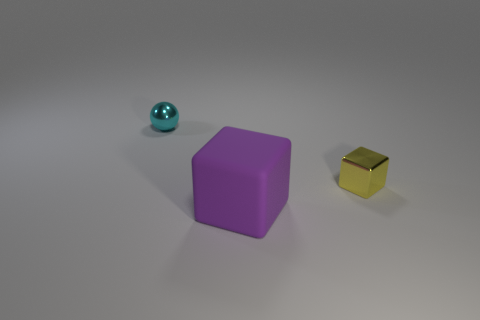Add 2 cyan spheres. How many objects exist? 5 Subtract all blue spheres. Subtract all red cubes. How many spheres are left? 1 Subtract all yellow cylinders. How many purple spheres are left? 0 Subtract all small metallic balls. Subtract all cyan metal things. How many objects are left? 1 Add 2 large cubes. How many large cubes are left? 3 Add 2 yellow objects. How many yellow objects exist? 3 Subtract 0 gray balls. How many objects are left? 3 Subtract all blocks. How many objects are left? 1 Subtract 1 balls. How many balls are left? 0 